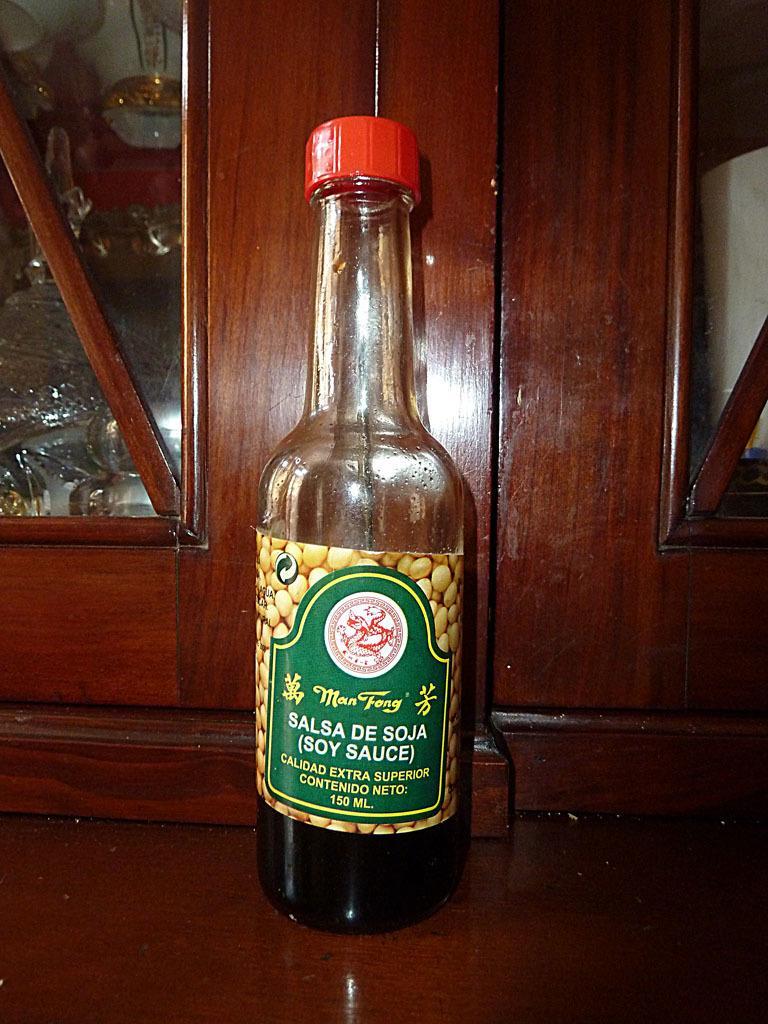In one or two sentences, can you explain what this image depicts? On the table there is a soy sauce bottle with a red color cap. Behind the bottle there is a cupboard. Inside the cupboard there are some items. 